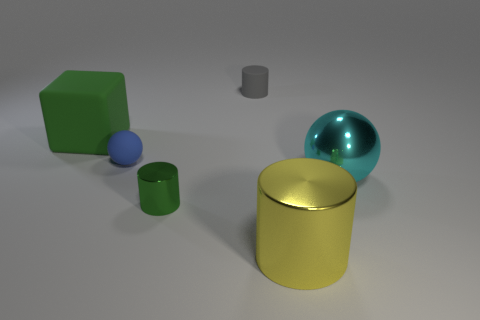What is the material of the green cylinder that is the same size as the blue thing?
Your answer should be very brief. Metal. How many objects are gray matte objects or tiny matte objects?
Your response must be concise. 2. How many large objects are both on the right side of the tiny blue rubber object and on the left side of the large cyan metal thing?
Keep it short and to the point. 1. Are there fewer tiny cylinders that are right of the tiny green cylinder than large green rubber things?
Ensure brevity in your answer.  No. What is the shape of the green thing that is the same size as the gray rubber thing?
Your answer should be very brief. Cylinder. What number of other things are there of the same color as the matte ball?
Make the answer very short. 0. Do the cyan object and the green matte block have the same size?
Give a very brief answer. Yes. What number of objects are tiny gray objects or cylinders that are behind the blue thing?
Offer a very short reply. 1. Are there fewer blue matte spheres in front of the tiny green object than objects that are left of the small gray thing?
Your answer should be very brief. Yes. What number of other objects are the same material as the yellow thing?
Provide a succinct answer. 2. 